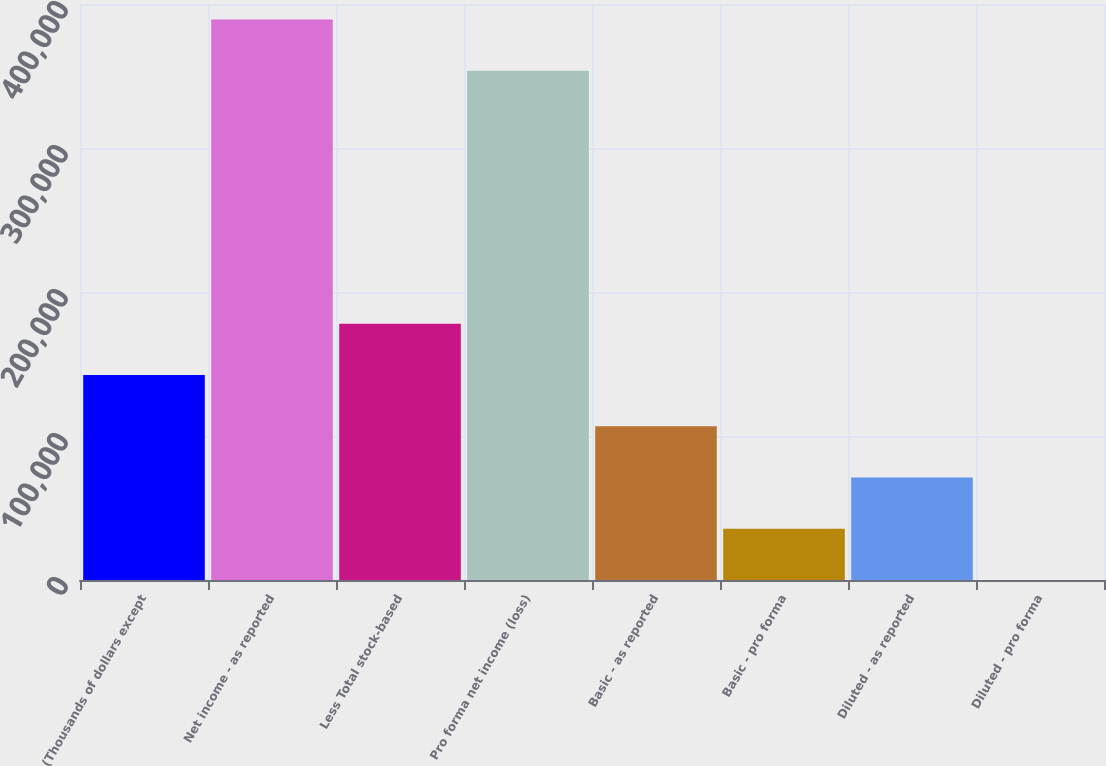Convert chart. <chart><loc_0><loc_0><loc_500><loc_500><bar_chart><fcel>(Thousands of dollars except<fcel>Net income - as reported<fcel>Less Total stock-based<fcel>Pro forma net income (loss)<fcel>Basic - as reported<fcel>Basic - pro forma<fcel>Diluted - as reported<fcel>Diluted - pro forma<nl><fcel>142385<fcel>389218<fcel>177981<fcel>353622<fcel>106789<fcel>35596.9<fcel>71192.9<fcel>0.86<nl></chart> 